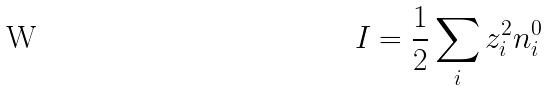<formula> <loc_0><loc_0><loc_500><loc_500>I = \frac { 1 } { 2 } \sum _ { i } z _ { i } ^ { 2 } n _ { i } ^ { 0 }</formula> 